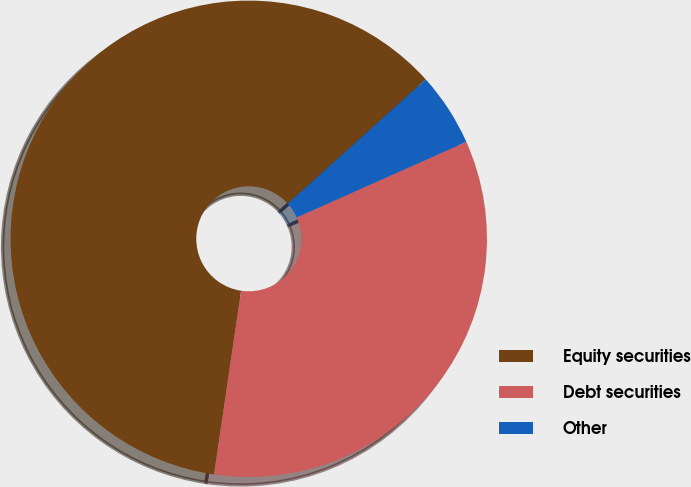Convert chart. <chart><loc_0><loc_0><loc_500><loc_500><pie_chart><fcel>Equity securities<fcel>Debt securities<fcel>Other<nl><fcel>61.0%<fcel>34.0%<fcel>5.0%<nl></chart> 